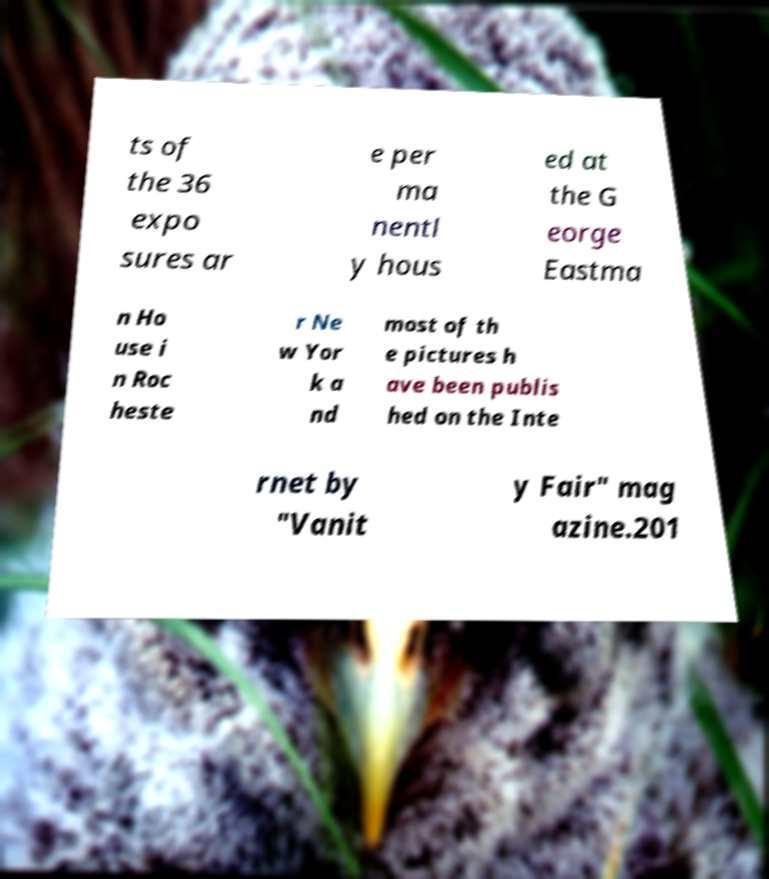Please read and relay the text visible in this image. What does it say? ts of the 36 expo sures ar e per ma nentl y hous ed at the G eorge Eastma n Ho use i n Roc heste r Ne w Yor k a nd most of th e pictures h ave been publis hed on the Inte rnet by "Vanit y Fair" mag azine.201 